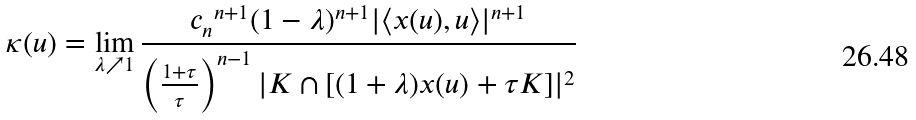<formula> <loc_0><loc_0><loc_500><loc_500>\kappa ( u ) = \lim _ { \lambda \nearrow 1 } \frac { { c _ { n } } ^ { n + 1 } ( 1 - \lambda ) ^ { n + 1 } | \langle x ( u ) , u \rangle | ^ { n + 1 } } { \left ( \frac { 1 + \tau } { \tau } \right ) ^ { n - 1 } | K \cap [ ( 1 + \lambda ) x ( u ) + \tau K ] | ^ { 2 } }</formula> 